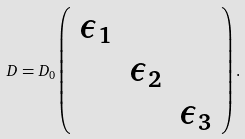Convert formula to latex. <formula><loc_0><loc_0><loc_500><loc_500>D = D _ { 0 } \left ( \begin{array} { c c c } \epsilon _ { 1 } & & \\ & \epsilon _ { 2 } & \\ & & \epsilon _ { 3 } \end{array} \right ) .</formula> 